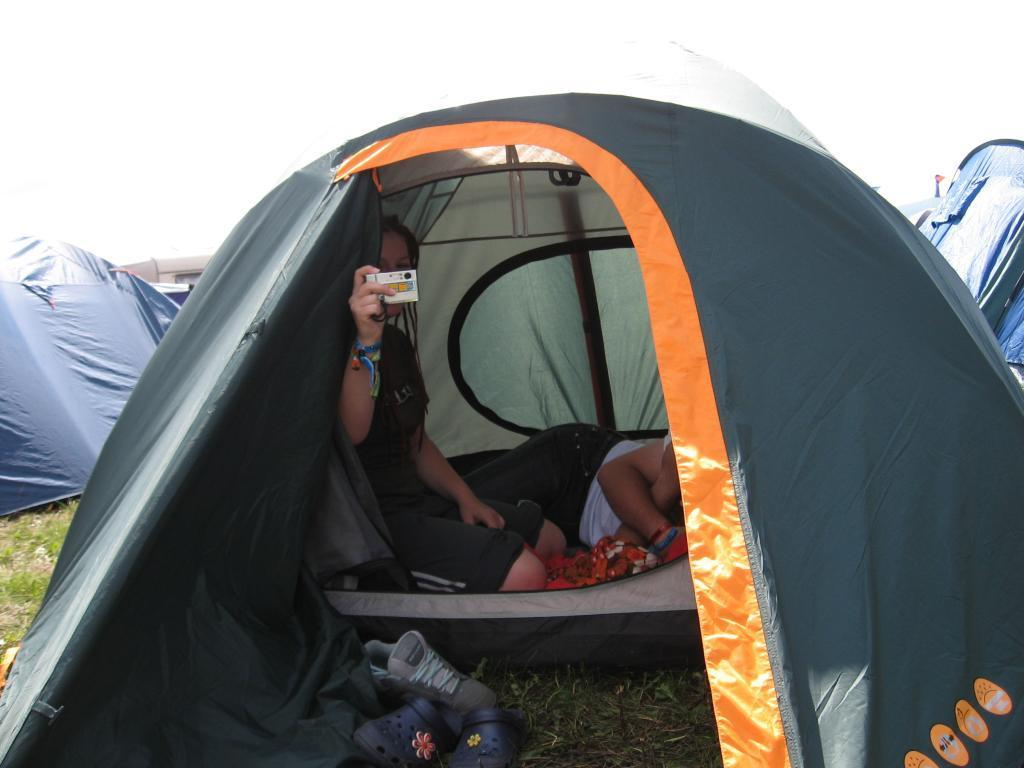What structures are present on the ground in the image? There are tents on the ground in the image. Can you describe the activity taking place inside one of the tents? There are two members inside one of the tents. What can be seen in the background of the image? The sky is visible in the background of the image. What type of fact is being recorded by the police in the image? There is no police or record-keeping activity present in the image. The image features tents and people inside them, with the sky visible in the background. 